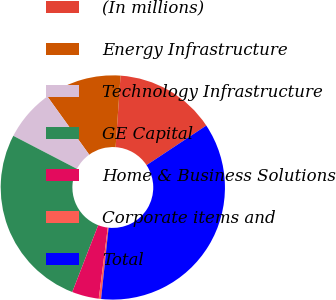Convert chart. <chart><loc_0><loc_0><loc_500><loc_500><pie_chart><fcel>(In millions)<fcel>Energy Infrastructure<fcel>Technology Infrastructure<fcel>GE Capital<fcel>Home & Business Solutions<fcel>Corporate items and<fcel>Total<nl><fcel>14.59%<fcel>11.02%<fcel>7.46%<fcel>26.73%<fcel>3.89%<fcel>0.33%<fcel>35.98%<nl></chart> 